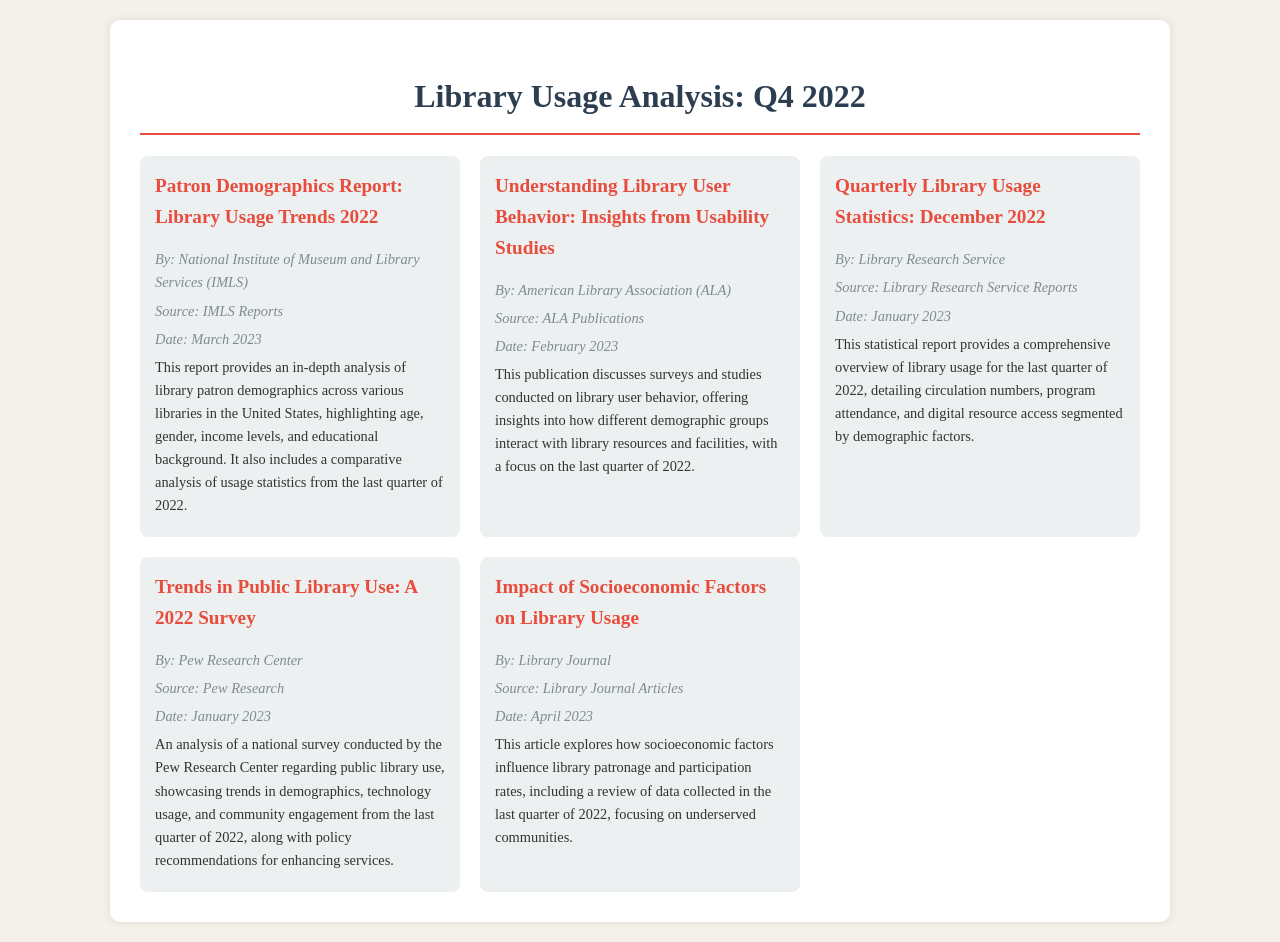What is the title of the first item in the schedule? The title of the first item is highlighted in bold and is "Patron Demographics Report: Library Usage Trends 2022."
Answer: Patron Demographics Report: Library Usage Trends 2022 Who authored the publication discussing library user behavior? The author of the publication is mentioned as "American Library Association (ALA)."
Answer: American Library Association (ALA) What date was the Quarterly Library Usage Statistics report published? The publication date is provided in the document as "January 2023."
Answer: January 2023 Which organization published the report on trends in public library use? The document states that the report was published by "Pew Research Center."
Answer: Pew Research Center How many items are listed in the schedule? The document presents a schedule with a total of five items listed.
Answer: Five What is the primary focus of the article by Library Journal? The article discusses how socio-economic factors influence library patronage, and this focus is described in the document.
Answer: Socioeconomic factors What type of data does the "Quarterly Library Usage Statistics: December 2022" report provide? The report includes statistics on circulation numbers, program attendance, and digital resource access segmented by demographic factors.
Answer: Statistics on circulation numbers, program attendance, and digital resource access Which publication discusses insights from usability studies? The second item in the schedule covers insights from user behavior studies and is authored by the ALA.
Answer: Understanding Library User Behavior: Insights from Usability Studies 